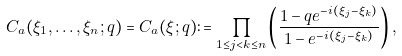<formula> <loc_0><loc_0><loc_500><loc_500>C _ { a } ( \xi _ { 1 } , \dots , \xi _ { n } ; q ) = C _ { a } ( \xi ; q ) \colon = \prod _ { 1 \leq j < k \leq n } \left ( \frac { 1 - q e ^ { - i ( \xi _ { j } - \xi _ { k } ) } } { 1 - e ^ { - i ( \xi _ { j } - \xi _ { k } ) } } \right ) ,</formula> 